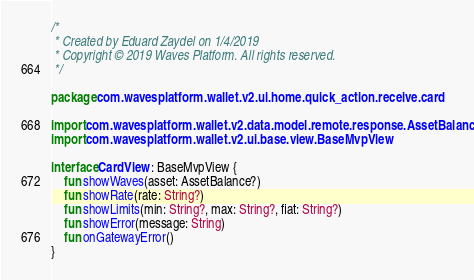Convert code to text. <code><loc_0><loc_0><loc_500><loc_500><_Kotlin_>/*
 * Created by Eduard Zaydel on 1/4/2019
 * Copyright © 2019 Waves Platform. All rights reserved.
 */

package com.wavesplatform.wallet.v2.ui.home.quick_action.receive.card

import com.wavesplatform.wallet.v2.data.model.remote.response.AssetBalance
import com.wavesplatform.wallet.v2.ui.base.view.BaseMvpView

interface CardView : BaseMvpView {
    fun showWaves(asset: AssetBalance?)
    fun showRate(rate: String?)
    fun showLimits(min: String?, max: String?, fiat: String?)
    fun showError(message: String)
    fun onGatewayError()
}
</code> 